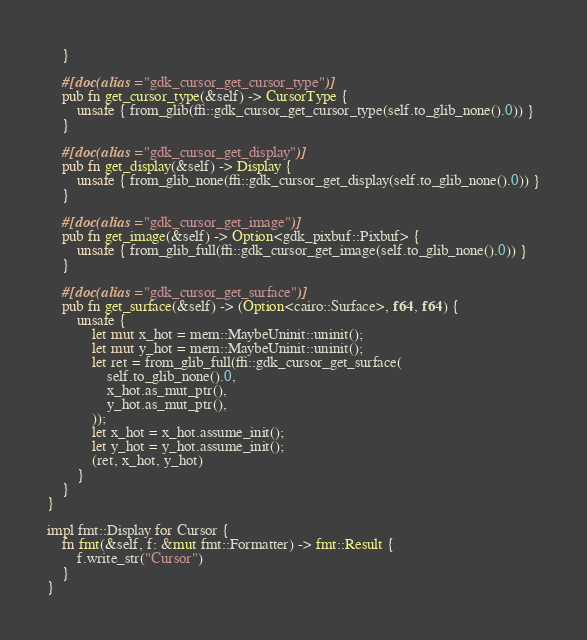<code> <loc_0><loc_0><loc_500><loc_500><_Rust_>    }

    #[doc(alias = "gdk_cursor_get_cursor_type")]
    pub fn get_cursor_type(&self) -> CursorType {
        unsafe { from_glib(ffi::gdk_cursor_get_cursor_type(self.to_glib_none().0)) }
    }

    #[doc(alias = "gdk_cursor_get_display")]
    pub fn get_display(&self) -> Display {
        unsafe { from_glib_none(ffi::gdk_cursor_get_display(self.to_glib_none().0)) }
    }

    #[doc(alias = "gdk_cursor_get_image")]
    pub fn get_image(&self) -> Option<gdk_pixbuf::Pixbuf> {
        unsafe { from_glib_full(ffi::gdk_cursor_get_image(self.to_glib_none().0)) }
    }

    #[doc(alias = "gdk_cursor_get_surface")]
    pub fn get_surface(&self) -> (Option<cairo::Surface>, f64, f64) {
        unsafe {
            let mut x_hot = mem::MaybeUninit::uninit();
            let mut y_hot = mem::MaybeUninit::uninit();
            let ret = from_glib_full(ffi::gdk_cursor_get_surface(
                self.to_glib_none().0,
                x_hot.as_mut_ptr(),
                y_hot.as_mut_ptr(),
            ));
            let x_hot = x_hot.assume_init();
            let y_hot = y_hot.assume_init();
            (ret, x_hot, y_hot)
        }
    }
}

impl fmt::Display for Cursor {
    fn fmt(&self, f: &mut fmt::Formatter) -> fmt::Result {
        f.write_str("Cursor")
    }
}
</code> 